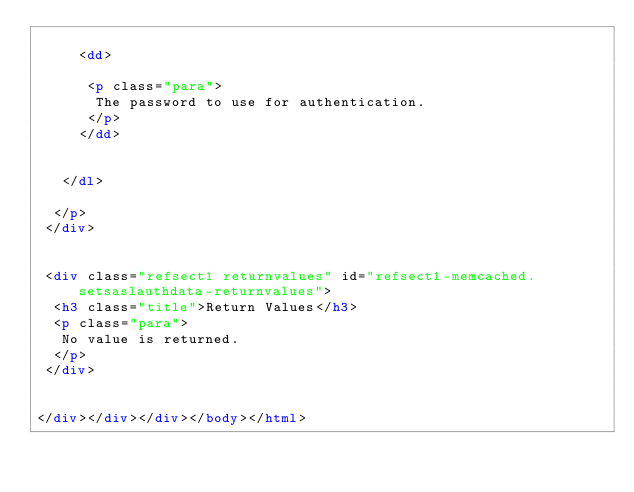<code> <loc_0><loc_0><loc_500><loc_500><_HTML_>
     <dd>

      <p class="para">
       The password to use for authentication.
      </p>
     </dd>

    
   </dl>

  </p>
 </div>


 <div class="refsect1 returnvalues" id="refsect1-memcached.setsaslauthdata-returnvalues">
  <h3 class="title">Return Values</h3>
  <p class="para">
   No value is returned.
  </p>
 </div>


</div></div></div></body></html></code> 